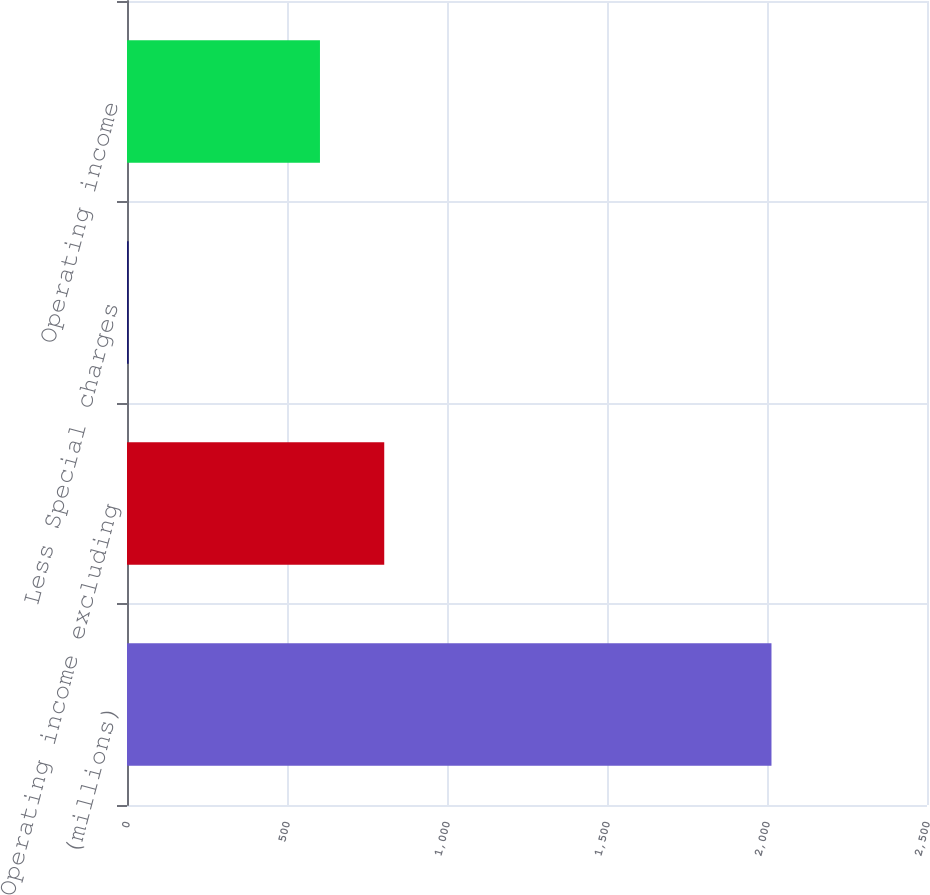<chart> <loc_0><loc_0><loc_500><loc_500><bar_chart><fcel>(millions)<fcel>Operating income excluding<fcel>Less Special charges<fcel>Operating income<nl><fcel>2014<fcel>803.88<fcel>5.2<fcel>603<nl></chart> 